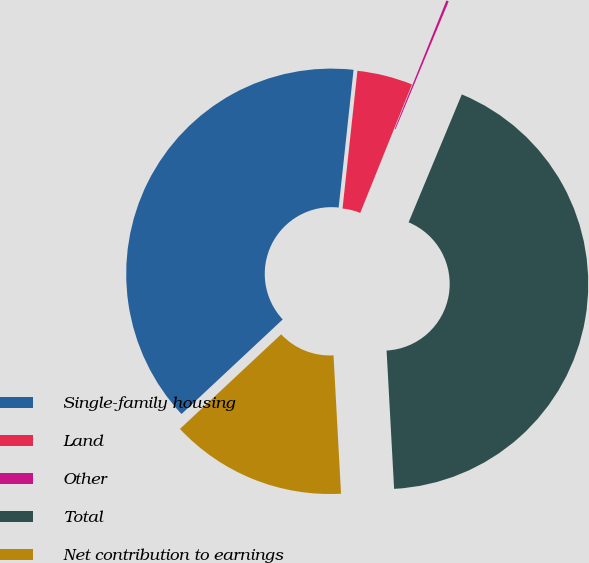Convert chart to OTSL. <chart><loc_0><loc_0><loc_500><loc_500><pie_chart><fcel>Single-family housing<fcel>Land<fcel>Other<fcel>Total<fcel>Net contribution to earnings<nl><fcel>38.68%<fcel>4.37%<fcel>0.19%<fcel>42.86%<fcel>13.9%<nl></chart> 